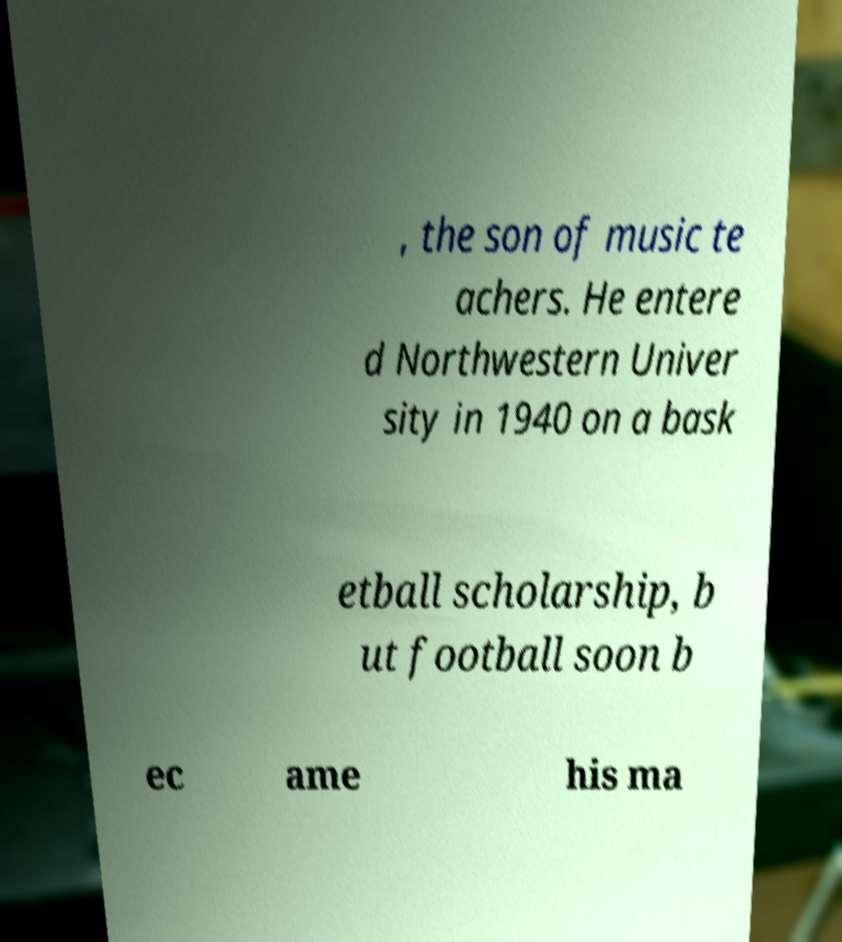There's text embedded in this image that I need extracted. Can you transcribe it verbatim? , the son of music te achers. He entere d Northwestern Univer sity in 1940 on a bask etball scholarship, b ut football soon b ec ame his ma 